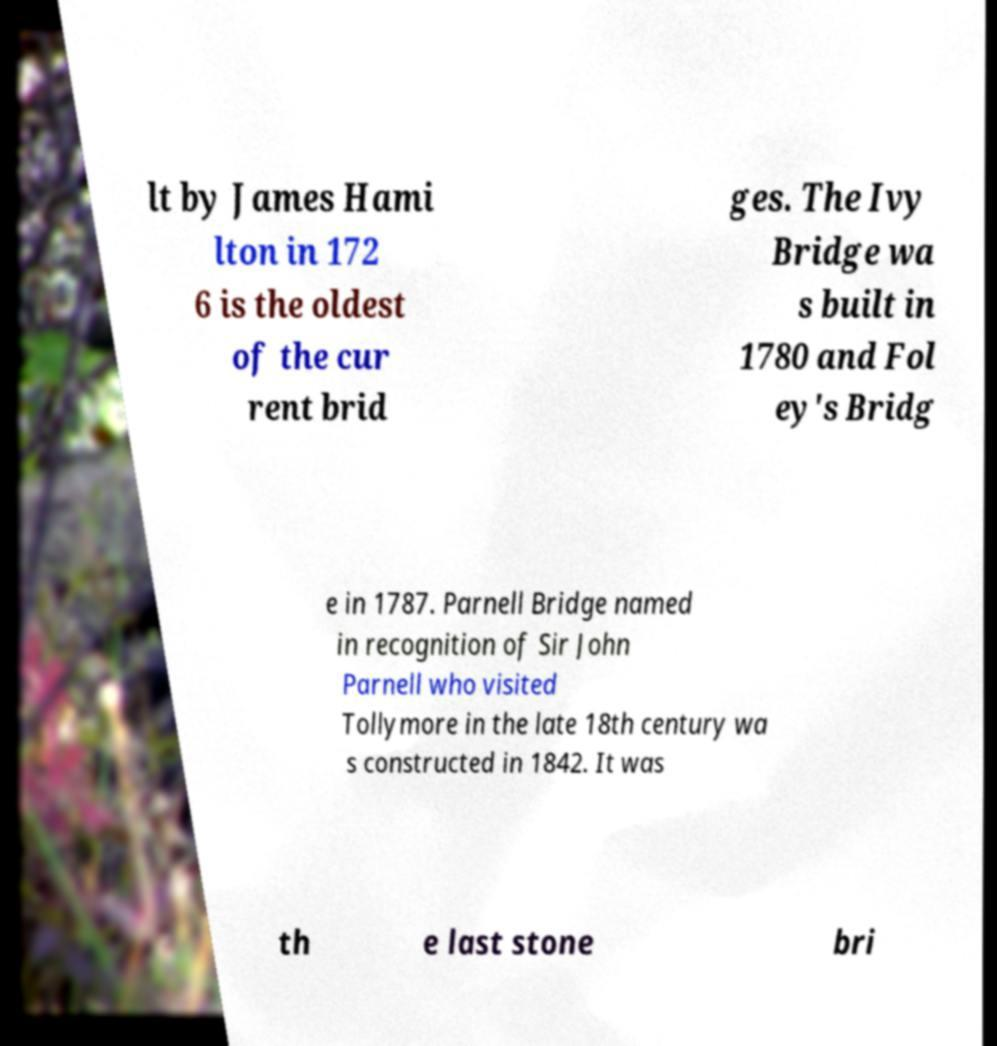Could you extract and type out the text from this image? lt by James Hami lton in 172 6 is the oldest of the cur rent brid ges. The Ivy Bridge wa s built in 1780 and Fol ey's Bridg e in 1787. Parnell Bridge named in recognition of Sir John Parnell who visited Tollymore in the late 18th century wa s constructed in 1842. It was th e last stone bri 